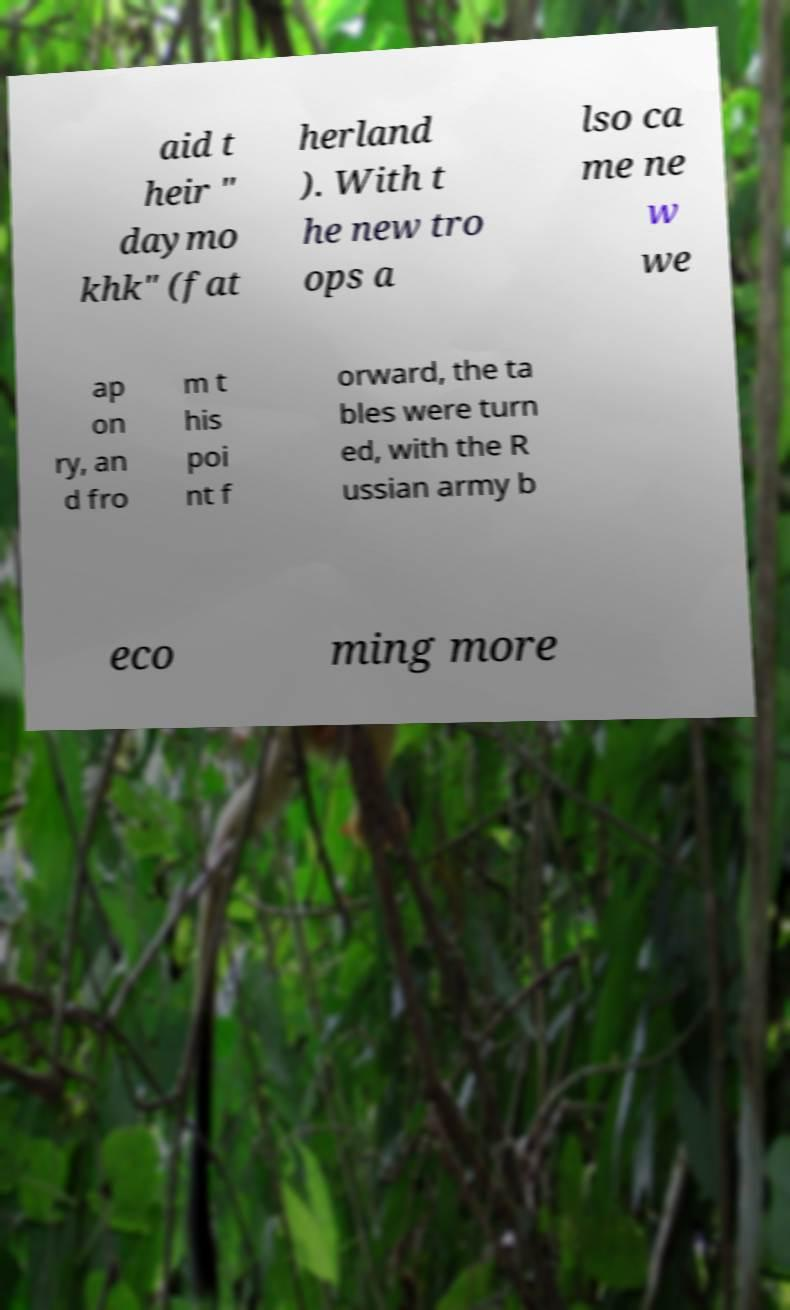What messages or text are displayed in this image? I need them in a readable, typed format. aid t heir " daymo khk" (fat herland ). With t he new tro ops a lso ca me ne w we ap on ry, an d fro m t his poi nt f orward, the ta bles were turn ed, with the R ussian army b eco ming more 